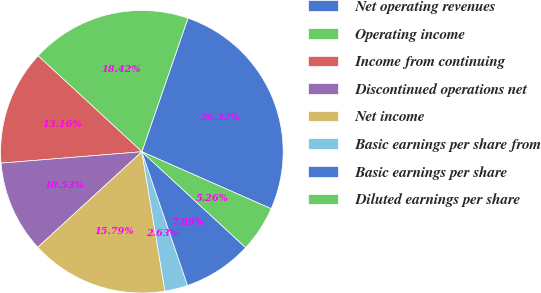Convert chart. <chart><loc_0><loc_0><loc_500><loc_500><pie_chart><fcel>Net operating revenues<fcel>Operating income<fcel>Income from continuing<fcel>Discontinued operations net<fcel>Net income<fcel>Basic earnings per share from<fcel>Basic earnings per share<fcel>Diluted earnings per share<nl><fcel>26.32%<fcel>18.42%<fcel>13.16%<fcel>10.53%<fcel>15.79%<fcel>2.63%<fcel>7.89%<fcel>5.26%<nl></chart> 